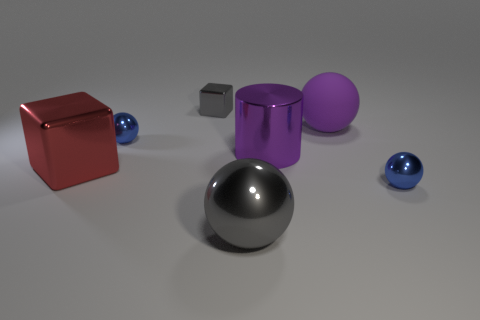There is a purple object left of the large purple ball; what is its material?
Offer a terse response. Metal. What number of other things are there of the same size as the cylinder?
Keep it short and to the point. 3. Does the purple cylinder have the same size as the gray thing left of the large gray shiny thing?
Make the answer very short. No. There is a tiny blue shiny thing on the right side of the gray metallic thing in front of the small blue sphere behind the big purple cylinder; what shape is it?
Your response must be concise. Sphere. Is the number of purple spheres less than the number of blue things?
Provide a succinct answer. Yes. There is a small gray metallic thing; are there any big purple balls to the left of it?
Make the answer very short. No. What is the shape of the object that is both right of the large purple cylinder and in front of the purple metallic thing?
Make the answer very short. Sphere. Are there any small blue metal objects of the same shape as the purple metallic thing?
Ensure brevity in your answer.  No. There is a blue sphere right of the big purple sphere; is its size the same as the blue thing that is on the left side of the cylinder?
Your response must be concise. Yes. Is the number of purple rubber objects greater than the number of blue balls?
Your answer should be very brief. No. 